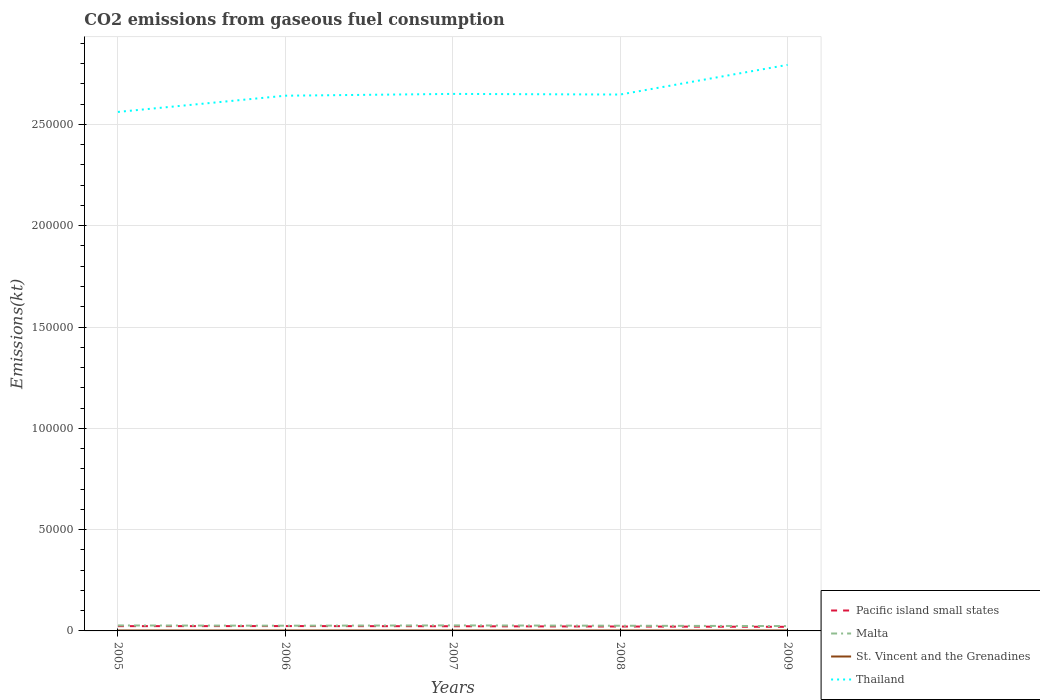Across all years, what is the maximum amount of CO2 emitted in Thailand?
Your answer should be compact. 2.56e+05. In which year was the amount of CO2 emitted in Malta maximum?
Your answer should be very brief. 2009. What is the total amount of CO2 emitted in Pacific island small states in the graph?
Your response must be concise. 284.35. What is the difference between the highest and the second highest amount of CO2 emitted in Malta?
Give a very brief answer. 333.7. What is the difference between the highest and the lowest amount of CO2 emitted in Pacific island small states?
Your response must be concise. 3. How many lines are there?
Provide a succinct answer. 4. How many years are there in the graph?
Give a very brief answer. 5. Does the graph contain any zero values?
Give a very brief answer. No. Where does the legend appear in the graph?
Offer a terse response. Bottom right. How many legend labels are there?
Your answer should be very brief. 4. What is the title of the graph?
Ensure brevity in your answer.  CO2 emissions from gaseous fuel consumption. Does "Greece" appear as one of the legend labels in the graph?
Your answer should be very brief. No. What is the label or title of the X-axis?
Your answer should be compact. Years. What is the label or title of the Y-axis?
Your response must be concise. Emissions(kt). What is the Emissions(kt) of Pacific island small states in 2005?
Ensure brevity in your answer.  2356.01. What is the Emissions(kt) in Malta in 2005?
Provide a succinct answer. 2698.91. What is the Emissions(kt) of St. Vincent and the Grenadines in 2005?
Offer a terse response. 220.02. What is the Emissions(kt) in Thailand in 2005?
Your answer should be very brief. 2.56e+05. What is the Emissions(kt) of Pacific island small states in 2006?
Your answer should be very brief. 2396.63. What is the Emissions(kt) in Malta in 2006?
Your response must be concise. 2574.23. What is the Emissions(kt) of St. Vincent and the Grenadines in 2006?
Your response must be concise. 220.02. What is the Emissions(kt) of Thailand in 2006?
Your answer should be very brief. 2.64e+05. What is the Emissions(kt) of Pacific island small states in 2007?
Give a very brief answer. 2308. What is the Emissions(kt) of Malta in 2007?
Offer a very short reply. 2724.58. What is the Emissions(kt) in St. Vincent and the Grenadines in 2007?
Ensure brevity in your answer.  227.35. What is the Emissions(kt) of Thailand in 2007?
Provide a short and direct response. 2.65e+05. What is the Emissions(kt) in Pacific island small states in 2008?
Provide a succinct answer. 2171.37. What is the Emissions(kt) in Malta in 2008?
Offer a terse response. 2559.57. What is the Emissions(kt) of St. Vincent and the Grenadines in 2008?
Provide a short and direct response. 231.02. What is the Emissions(kt) of Thailand in 2008?
Offer a very short reply. 2.65e+05. What is the Emissions(kt) of Pacific island small states in 2009?
Your response must be concise. 2023.65. What is the Emissions(kt) in Malta in 2009?
Offer a very short reply. 2390.88. What is the Emissions(kt) in St. Vincent and the Grenadines in 2009?
Provide a succinct answer. 231.02. What is the Emissions(kt) of Thailand in 2009?
Your answer should be very brief. 2.79e+05. Across all years, what is the maximum Emissions(kt) of Pacific island small states?
Make the answer very short. 2396.63. Across all years, what is the maximum Emissions(kt) in Malta?
Your answer should be very brief. 2724.58. Across all years, what is the maximum Emissions(kt) of St. Vincent and the Grenadines?
Give a very brief answer. 231.02. Across all years, what is the maximum Emissions(kt) of Thailand?
Provide a short and direct response. 2.79e+05. Across all years, what is the minimum Emissions(kt) in Pacific island small states?
Your response must be concise. 2023.65. Across all years, what is the minimum Emissions(kt) of Malta?
Make the answer very short. 2390.88. Across all years, what is the minimum Emissions(kt) of St. Vincent and the Grenadines?
Offer a very short reply. 220.02. Across all years, what is the minimum Emissions(kt) in Thailand?
Provide a succinct answer. 2.56e+05. What is the total Emissions(kt) in Pacific island small states in the graph?
Ensure brevity in your answer.  1.13e+04. What is the total Emissions(kt) in Malta in the graph?
Make the answer very short. 1.29e+04. What is the total Emissions(kt) in St. Vincent and the Grenadines in the graph?
Ensure brevity in your answer.  1129.44. What is the total Emissions(kt) in Thailand in the graph?
Give a very brief answer. 1.33e+06. What is the difference between the Emissions(kt) of Pacific island small states in 2005 and that in 2006?
Your response must be concise. -40.62. What is the difference between the Emissions(kt) of Malta in 2005 and that in 2006?
Provide a short and direct response. 124.68. What is the difference between the Emissions(kt) in Thailand in 2005 and that in 2006?
Make the answer very short. -8012.4. What is the difference between the Emissions(kt) in Pacific island small states in 2005 and that in 2007?
Give a very brief answer. 48.01. What is the difference between the Emissions(kt) of Malta in 2005 and that in 2007?
Provide a succinct answer. -25.67. What is the difference between the Emissions(kt) in St. Vincent and the Grenadines in 2005 and that in 2007?
Your response must be concise. -7.33. What is the difference between the Emissions(kt) in Thailand in 2005 and that in 2007?
Your response must be concise. -8892.48. What is the difference between the Emissions(kt) in Pacific island small states in 2005 and that in 2008?
Your answer should be very brief. 184.64. What is the difference between the Emissions(kt) in Malta in 2005 and that in 2008?
Your answer should be compact. 139.35. What is the difference between the Emissions(kt) in St. Vincent and the Grenadines in 2005 and that in 2008?
Offer a terse response. -11. What is the difference between the Emissions(kt) of Thailand in 2005 and that in 2008?
Make the answer very short. -8584.45. What is the difference between the Emissions(kt) of Pacific island small states in 2005 and that in 2009?
Provide a succinct answer. 332.35. What is the difference between the Emissions(kt) in Malta in 2005 and that in 2009?
Give a very brief answer. 308.03. What is the difference between the Emissions(kt) of St. Vincent and the Grenadines in 2005 and that in 2009?
Provide a short and direct response. -11. What is the difference between the Emissions(kt) in Thailand in 2005 and that in 2009?
Offer a very short reply. -2.32e+04. What is the difference between the Emissions(kt) of Pacific island small states in 2006 and that in 2007?
Offer a very short reply. 88.63. What is the difference between the Emissions(kt) of Malta in 2006 and that in 2007?
Your answer should be very brief. -150.35. What is the difference between the Emissions(kt) of St. Vincent and the Grenadines in 2006 and that in 2007?
Your answer should be compact. -7.33. What is the difference between the Emissions(kt) in Thailand in 2006 and that in 2007?
Give a very brief answer. -880.08. What is the difference between the Emissions(kt) in Pacific island small states in 2006 and that in 2008?
Your response must be concise. 225.26. What is the difference between the Emissions(kt) of Malta in 2006 and that in 2008?
Ensure brevity in your answer.  14.67. What is the difference between the Emissions(kt) of St. Vincent and the Grenadines in 2006 and that in 2008?
Provide a short and direct response. -11. What is the difference between the Emissions(kt) in Thailand in 2006 and that in 2008?
Your response must be concise. -572.05. What is the difference between the Emissions(kt) in Pacific island small states in 2006 and that in 2009?
Your response must be concise. 372.97. What is the difference between the Emissions(kt) of Malta in 2006 and that in 2009?
Give a very brief answer. 183.35. What is the difference between the Emissions(kt) of St. Vincent and the Grenadines in 2006 and that in 2009?
Your answer should be compact. -11. What is the difference between the Emissions(kt) of Thailand in 2006 and that in 2009?
Your response must be concise. -1.52e+04. What is the difference between the Emissions(kt) of Pacific island small states in 2007 and that in 2008?
Offer a terse response. 136.63. What is the difference between the Emissions(kt) in Malta in 2007 and that in 2008?
Your answer should be compact. 165.01. What is the difference between the Emissions(kt) in St. Vincent and the Grenadines in 2007 and that in 2008?
Keep it short and to the point. -3.67. What is the difference between the Emissions(kt) of Thailand in 2007 and that in 2008?
Ensure brevity in your answer.  308.03. What is the difference between the Emissions(kt) in Pacific island small states in 2007 and that in 2009?
Your answer should be very brief. 284.35. What is the difference between the Emissions(kt) in Malta in 2007 and that in 2009?
Offer a terse response. 333.7. What is the difference between the Emissions(kt) of St. Vincent and the Grenadines in 2007 and that in 2009?
Offer a very short reply. -3.67. What is the difference between the Emissions(kt) in Thailand in 2007 and that in 2009?
Keep it short and to the point. -1.43e+04. What is the difference between the Emissions(kt) of Pacific island small states in 2008 and that in 2009?
Your response must be concise. 147.71. What is the difference between the Emissions(kt) of Malta in 2008 and that in 2009?
Your response must be concise. 168.68. What is the difference between the Emissions(kt) in Thailand in 2008 and that in 2009?
Offer a very short reply. -1.46e+04. What is the difference between the Emissions(kt) in Pacific island small states in 2005 and the Emissions(kt) in Malta in 2006?
Provide a short and direct response. -218.23. What is the difference between the Emissions(kt) in Pacific island small states in 2005 and the Emissions(kt) in St. Vincent and the Grenadines in 2006?
Your response must be concise. 2135.99. What is the difference between the Emissions(kt) in Pacific island small states in 2005 and the Emissions(kt) in Thailand in 2006?
Provide a succinct answer. -2.62e+05. What is the difference between the Emissions(kt) of Malta in 2005 and the Emissions(kt) of St. Vincent and the Grenadines in 2006?
Ensure brevity in your answer.  2478.89. What is the difference between the Emissions(kt) of Malta in 2005 and the Emissions(kt) of Thailand in 2006?
Your answer should be very brief. -2.61e+05. What is the difference between the Emissions(kt) in St. Vincent and the Grenadines in 2005 and the Emissions(kt) in Thailand in 2006?
Your response must be concise. -2.64e+05. What is the difference between the Emissions(kt) in Pacific island small states in 2005 and the Emissions(kt) in Malta in 2007?
Provide a short and direct response. -368.57. What is the difference between the Emissions(kt) in Pacific island small states in 2005 and the Emissions(kt) in St. Vincent and the Grenadines in 2007?
Provide a succinct answer. 2128.65. What is the difference between the Emissions(kt) in Pacific island small states in 2005 and the Emissions(kt) in Thailand in 2007?
Make the answer very short. -2.63e+05. What is the difference between the Emissions(kt) in Malta in 2005 and the Emissions(kt) in St. Vincent and the Grenadines in 2007?
Ensure brevity in your answer.  2471.56. What is the difference between the Emissions(kt) in Malta in 2005 and the Emissions(kt) in Thailand in 2007?
Make the answer very short. -2.62e+05. What is the difference between the Emissions(kt) in St. Vincent and the Grenadines in 2005 and the Emissions(kt) in Thailand in 2007?
Ensure brevity in your answer.  -2.65e+05. What is the difference between the Emissions(kt) of Pacific island small states in 2005 and the Emissions(kt) of Malta in 2008?
Your answer should be compact. -203.56. What is the difference between the Emissions(kt) of Pacific island small states in 2005 and the Emissions(kt) of St. Vincent and the Grenadines in 2008?
Your response must be concise. 2124.99. What is the difference between the Emissions(kt) of Pacific island small states in 2005 and the Emissions(kt) of Thailand in 2008?
Offer a terse response. -2.62e+05. What is the difference between the Emissions(kt) in Malta in 2005 and the Emissions(kt) in St. Vincent and the Grenadines in 2008?
Provide a succinct answer. 2467.89. What is the difference between the Emissions(kt) in Malta in 2005 and the Emissions(kt) in Thailand in 2008?
Ensure brevity in your answer.  -2.62e+05. What is the difference between the Emissions(kt) in St. Vincent and the Grenadines in 2005 and the Emissions(kt) in Thailand in 2008?
Offer a terse response. -2.65e+05. What is the difference between the Emissions(kt) of Pacific island small states in 2005 and the Emissions(kt) of Malta in 2009?
Your answer should be very brief. -34.88. What is the difference between the Emissions(kt) of Pacific island small states in 2005 and the Emissions(kt) of St. Vincent and the Grenadines in 2009?
Make the answer very short. 2124.99. What is the difference between the Emissions(kt) of Pacific island small states in 2005 and the Emissions(kt) of Thailand in 2009?
Ensure brevity in your answer.  -2.77e+05. What is the difference between the Emissions(kt) of Malta in 2005 and the Emissions(kt) of St. Vincent and the Grenadines in 2009?
Ensure brevity in your answer.  2467.89. What is the difference between the Emissions(kt) in Malta in 2005 and the Emissions(kt) in Thailand in 2009?
Offer a terse response. -2.77e+05. What is the difference between the Emissions(kt) of St. Vincent and the Grenadines in 2005 and the Emissions(kt) of Thailand in 2009?
Your answer should be very brief. -2.79e+05. What is the difference between the Emissions(kt) in Pacific island small states in 2006 and the Emissions(kt) in Malta in 2007?
Keep it short and to the point. -327.95. What is the difference between the Emissions(kt) in Pacific island small states in 2006 and the Emissions(kt) in St. Vincent and the Grenadines in 2007?
Offer a terse response. 2169.27. What is the difference between the Emissions(kt) of Pacific island small states in 2006 and the Emissions(kt) of Thailand in 2007?
Provide a short and direct response. -2.63e+05. What is the difference between the Emissions(kt) of Malta in 2006 and the Emissions(kt) of St. Vincent and the Grenadines in 2007?
Provide a succinct answer. 2346.88. What is the difference between the Emissions(kt) in Malta in 2006 and the Emissions(kt) in Thailand in 2007?
Provide a succinct answer. -2.62e+05. What is the difference between the Emissions(kt) in St. Vincent and the Grenadines in 2006 and the Emissions(kt) in Thailand in 2007?
Offer a very short reply. -2.65e+05. What is the difference between the Emissions(kt) in Pacific island small states in 2006 and the Emissions(kt) in Malta in 2008?
Your answer should be very brief. -162.94. What is the difference between the Emissions(kt) of Pacific island small states in 2006 and the Emissions(kt) of St. Vincent and the Grenadines in 2008?
Give a very brief answer. 2165.61. What is the difference between the Emissions(kt) in Pacific island small states in 2006 and the Emissions(kt) in Thailand in 2008?
Give a very brief answer. -2.62e+05. What is the difference between the Emissions(kt) in Malta in 2006 and the Emissions(kt) in St. Vincent and the Grenadines in 2008?
Provide a succinct answer. 2343.21. What is the difference between the Emissions(kt) in Malta in 2006 and the Emissions(kt) in Thailand in 2008?
Your response must be concise. -2.62e+05. What is the difference between the Emissions(kt) in St. Vincent and the Grenadines in 2006 and the Emissions(kt) in Thailand in 2008?
Make the answer very short. -2.65e+05. What is the difference between the Emissions(kt) in Pacific island small states in 2006 and the Emissions(kt) in Malta in 2009?
Your answer should be compact. 5.74. What is the difference between the Emissions(kt) in Pacific island small states in 2006 and the Emissions(kt) in St. Vincent and the Grenadines in 2009?
Your answer should be compact. 2165.61. What is the difference between the Emissions(kt) in Pacific island small states in 2006 and the Emissions(kt) in Thailand in 2009?
Provide a succinct answer. -2.77e+05. What is the difference between the Emissions(kt) of Malta in 2006 and the Emissions(kt) of St. Vincent and the Grenadines in 2009?
Provide a succinct answer. 2343.21. What is the difference between the Emissions(kt) of Malta in 2006 and the Emissions(kt) of Thailand in 2009?
Ensure brevity in your answer.  -2.77e+05. What is the difference between the Emissions(kt) of St. Vincent and the Grenadines in 2006 and the Emissions(kt) of Thailand in 2009?
Offer a terse response. -2.79e+05. What is the difference between the Emissions(kt) in Pacific island small states in 2007 and the Emissions(kt) in Malta in 2008?
Give a very brief answer. -251.57. What is the difference between the Emissions(kt) in Pacific island small states in 2007 and the Emissions(kt) in St. Vincent and the Grenadines in 2008?
Your response must be concise. 2076.98. What is the difference between the Emissions(kt) of Pacific island small states in 2007 and the Emissions(kt) of Thailand in 2008?
Provide a succinct answer. -2.62e+05. What is the difference between the Emissions(kt) in Malta in 2007 and the Emissions(kt) in St. Vincent and the Grenadines in 2008?
Provide a succinct answer. 2493.56. What is the difference between the Emissions(kt) in Malta in 2007 and the Emissions(kt) in Thailand in 2008?
Your answer should be compact. -2.62e+05. What is the difference between the Emissions(kt) in St. Vincent and the Grenadines in 2007 and the Emissions(kt) in Thailand in 2008?
Provide a succinct answer. -2.65e+05. What is the difference between the Emissions(kt) in Pacific island small states in 2007 and the Emissions(kt) in Malta in 2009?
Give a very brief answer. -82.88. What is the difference between the Emissions(kt) in Pacific island small states in 2007 and the Emissions(kt) in St. Vincent and the Grenadines in 2009?
Ensure brevity in your answer.  2076.98. What is the difference between the Emissions(kt) of Pacific island small states in 2007 and the Emissions(kt) of Thailand in 2009?
Your answer should be very brief. -2.77e+05. What is the difference between the Emissions(kt) in Malta in 2007 and the Emissions(kt) in St. Vincent and the Grenadines in 2009?
Offer a terse response. 2493.56. What is the difference between the Emissions(kt) of Malta in 2007 and the Emissions(kt) of Thailand in 2009?
Offer a terse response. -2.77e+05. What is the difference between the Emissions(kt) of St. Vincent and the Grenadines in 2007 and the Emissions(kt) of Thailand in 2009?
Keep it short and to the point. -2.79e+05. What is the difference between the Emissions(kt) of Pacific island small states in 2008 and the Emissions(kt) of Malta in 2009?
Offer a terse response. -219.52. What is the difference between the Emissions(kt) of Pacific island small states in 2008 and the Emissions(kt) of St. Vincent and the Grenadines in 2009?
Make the answer very short. 1940.35. What is the difference between the Emissions(kt) in Pacific island small states in 2008 and the Emissions(kt) in Thailand in 2009?
Keep it short and to the point. -2.77e+05. What is the difference between the Emissions(kt) of Malta in 2008 and the Emissions(kt) of St. Vincent and the Grenadines in 2009?
Ensure brevity in your answer.  2328.55. What is the difference between the Emissions(kt) in Malta in 2008 and the Emissions(kt) in Thailand in 2009?
Give a very brief answer. -2.77e+05. What is the difference between the Emissions(kt) in St. Vincent and the Grenadines in 2008 and the Emissions(kt) in Thailand in 2009?
Ensure brevity in your answer.  -2.79e+05. What is the average Emissions(kt) of Pacific island small states per year?
Offer a very short reply. 2251.13. What is the average Emissions(kt) of Malta per year?
Your answer should be compact. 2589.64. What is the average Emissions(kt) of St. Vincent and the Grenadines per year?
Give a very brief answer. 225.89. What is the average Emissions(kt) of Thailand per year?
Provide a short and direct response. 2.66e+05. In the year 2005, what is the difference between the Emissions(kt) in Pacific island small states and Emissions(kt) in Malta?
Your response must be concise. -342.91. In the year 2005, what is the difference between the Emissions(kt) in Pacific island small states and Emissions(kt) in St. Vincent and the Grenadines?
Offer a very short reply. 2135.99. In the year 2005, what is the difference between the Emissions(kt) of Pacific island small states and Emissions(kt) of Thailand?
Provide a succinct answer. -2.54e+05. In the year 2005, what is the difference between the Emissions(kt) in Malta and Emissions(kt) in St. Vincent and the Grenadines?
Offer a very short reply. 2478.89. In the year 2005, what is the difference between the Emissions(kt) of Malta and Emissions(kt) of Thailand?
Make the answer very short. -2.53e+05. In the year 2005, what is the difference between the Emissions(kt) of St. Vincent and the Grenadines and Emissions(kt) of Thailand?
Your answer should be compact. -2.56e+05. In the year 2006, what is the difference between the Emissions(kt) in Pacific island small states and Emissions(kt) in Malta?
Your answer should be compact. -177.61. In the year 2006, what is the difference between the Emissions(kt) in Pacific island small states and Emissions(kt) in St. Vincent and the Grenadines?
Your response must be concise. 2176.61. In the year 2006, what is the difference between the Emissions(kt) of Pacific island small states and Emissions(kt) of Thailand?
Your answer should be very brief. -2.62e+05. In the year 2006, what is the difference between the Emissions(kt) of Malta and Emissions(kt) of St. Vincent and the Grenadines?
Provide a short and direct response. 2354.21. In the year 2006, what is the difference between the Emissions(kt) in Malta and Emissions(kt) in Thailand?
Your response must be concise. -2.62e+05. In the year 2006, what is the difference between the Emissions(kt) in St. Vincent and the Grenadines and Emissions(kt) in Thailand?
Your answer should be compact. -2.64e+05. In the year 2007, what is the difference between the Emissions(kt) in Pacific island small states and Emissions(kt) in Malta?
Ensure brevity in your answer.  -416.58. In the year 2007, what is the difference between the Emissions(kt) in Pacific island small states and Emissions(kt) in St. Vincent and the Grenadines?
Your response must be concise. 2080.65. In the year 2007, what is the difference between the Emissions(kt) in Pacific island small states and Emissions(kt) in Thailand?
Offer a very short reply. -2.63e+05. In the year 2007, what is the difference between the Emissions(kt) of Malta and Emissions(kt) of St. Vincent and the Grenadines?
Keep it short and to the point. 2497.23. In the year 2007, what is the difference between the Emissions(kt) in Malta and Emissions(kt) in Thailand?
Your answer should be compact. -2.62e+05. In the year 2007, what is the difference between the Emissions(kt) in St. Vincent and the Grenadines and Emissions(kt) in Thailand?
Make the answer very short. -2.65e+05. In the year 2008, what is the difference between the Emissions(kt) in Pacific island small states and Emissions(kt) in Malta?
Ensure brevity in your answer.  -388.2. In the year 2008, what is the difference between the Emissions(kt) of Pacific island small states and Emissions(kt) of St. Vincent and the Grenadines?
Give a very brief answer. 1940.35. In the year 2008, what is the difference between the Emissions(kt) of Pacific island small states and Emissions(kt) of Thailand?
Your answer should be very brief. -2.63e+05. In the year 2008, what is the difference between the Emissions(kt) in Malta and Emissions(kt) in St. Vincent and the Grenadines?
Your answer should be compact. 2328.55. In the year 2008, what is the difference between the Emissions(kt) of Malta and Emissions(kt) of Thailand?
Your answer should be compact. -2.62e+05. In the year 2008, what is the difference between the Emissions(kt) of St. Vincent and the Grenadines and Emissions(kt) of Thailand?
Give a very brief answer. -2.65e+05. In the year 2009, what is the difference between the Emissions(kt) of Pacific island small states and Emissions(kt) of Malta?
Your response must be concise. -367.23. In the year 2009, what is the difference between the Emissions(kt) of Pacific island small states and Emissions(kt) of St. Vincent and the Grenadines?
Your answer should be very brief. 1792.63. In the year 2009, what is the difference between the Emissions(kt) of Pacific island small states and Emissions(kt) of Thailand?
Ensure brevity in your answer.  -2.77e+05. In the year 2009, what is the difference between the Emissions(kt) of Malta and Emissions(kt) of St. Vincent and the Grenadines?
Ensure brevity in your answer.  2159.86. In the year 2009, what is the difference between the Emissions(kt) of Malta and Emissions(kt) of Thailand?
Your answer should be compact. -2.77e+05. In the year 2009, what is the difference between the Emissions(kt) in St. Vincent and the Grenadines and Emissions(kt) in Thailand?
Your answer should be very brief. -2.79e+05. What is the ratio of the Emissions(kt) in Pacific island small states in 2005 to that in 2006?
Make the answer very short. 0.98. What is the ratio of the Emissions(kt) of Malta in 2005 to that in 2006?
Offer a terse response. 1.05. What is the ratio of the Emissions(kt) of St. Vincent and the Grenadines in 2005 to that in 2006?
Ensure brevity in your answer.  1. What is the ratio of the Emissions(kt) of Thailand in 2005 to that in 2006?
Provide a succinct answer. 0.97. What is the ratio of the Emissions(kt) in Pacific island small states in 2005 to that in 2007?
Your response must be concise. 1.02. What is the ratio of the Emissions(kt) of Malta in 2005 to that in 2007?
Keep it short and to the point. 0.99. What is the ratio of the Emissions(kt) of Thailand in 2005 to that in 2007?
Your answer should be very brief. 0.97. What is the ratio of the Emissions(kt) in Pacific island small states in 2005 to that in 2008?
Make the answer very short. 1.08. What is the ratio of the Emissions(kt) in Malta in 2005 to that in 2008?
Keep it short and to the point. 1.05. What is the ratio of the Emissions(kt) in Thailand in 2005 to that in 2008?
Provide a succinct answer. 0.97. What is the ratio of the Emissions(kt) of Pacific island small states in 2005 to that in 2009?
Offer a terse response. 1.16. What is the ratio of the Emissions(kt) of Malta in 2005 to that in 2009?
Provide a short and direct response. 1.13. What is the ratio of the Emissions(kt) of Thailand in 2005 to that in 2009?
Provide a succinct answer. 0.92. What is the ratio of the Emissions(kt) in Pacific island small states in 2006 to that in 2007?
Ensure brevity in your answer.  1.04. What is the ratio of the Emissions(kt) of Malta in 2006 to that in 2007?
Your answer should be very brief. 0.94. What is the ratio of the Emissions(kt) in Pacific island small states in 2006 to that in 2008?
Provide a short and direct response. 1.1. What is the ratio of the Emissions(kt) of St. Vincent and the Grenadines in 2006 to that in 2008?
Offer a very short reply. 0.95. What is the ratio of the Emissions(kt) of Thailand in 2006 to that in 2008?
Give a very brief answer. 1. What is the ratio of the Emissions(kt) in Pacific island small states in 2006 to that in 2009?
Offer a very short reply. 1.18. What is the ratio of the Emissions(kt) in Malta in 2006 to that in 2009?
Provide a short and direct response. 1.08. What is the ratio of the Emissions(kt) in St. Vincent and the Grenadines in 2006 to that in 2009?
Give a very brief answer. 0.95. What is the ratio of the Emissions(kt) of Thailand in 2006 to that in 2009?
Ensure brevity in your answer.  0.95. What is the ratio of the Emissions(kt) of Pacific island small states in 2007 to that in 2008?
Provide a succinct answer. 1.06. What is the ratio of the Emissions(kt) in Malta in 2007 to that in 2008?
Provide a succinct answer. 1.06. What is the ratio of the Emissions(kt) of St. Vincent and the Grenadines in 2007 to that in 2008?
Your response must be concise. 0.98. What is the ratio of the Emissions(kt) of Pacific island small states in 2007 to that in 2009?
Your response must be concise. 1.14. What is the ratio of the Emissions(kt) in Malta in 2007 to that in 2009?
Make the answer very short. 1.14. What is the ratio of the Emissions(kt) in St. Vincent and the Grenadines in 2007 to that in 2009?
Make the answer very short. 0.98. What is the ratio of the Emissions(kt) of Thailand in 2007 to that in 2009?
Your response must be concise. 0.95. What is the ratio of the Emissions(kt) in Pacific island small states in 2008 to that in 2009?
Provide a succinct answer. 1.07. What is the ratio of the Emissions(kt) of Malta in 2008 to that in 2009?
Offer a terse response. 1.07. What is the ratio of the Emissions(kt) of Thailand in 2008 to that in 2009?
Offer a very short reply. 0.95. What is the difference between the highest and the second highest Emissions(kt) of Pacific island small states?
Offer a very short reply. 40.62. What is the difference between the highest and the second highest Emissions(kt) in Malta?
Offer a very short reply. 25.67. What is the difference between the highest and the second highest Emissions(kt) of St. Vincent and the Grenadines?
Offer a very short reply. 0. What is the difference between the highest and the second highest Emissions(kt) of Thailand?
Offer a very short reply. 1.43e+04. What is the difference between the highest and the lowest Emissions(kt) of Pacific island small states?
Ensure brevity in your answer.  372.97. What is the difference between the highest and the lowest Emissions(kt) in Malta?
Give a very brief answer. 333.7. What is the difference between the highest and the lowest Emissions(kt) of St. Vincent and the Grenadines?
Offer a terse response. 11. What is the difference between the highest and the lowest Emissions(kt) of Thailand?
Provide a short and direct response. 2.32e+04. 